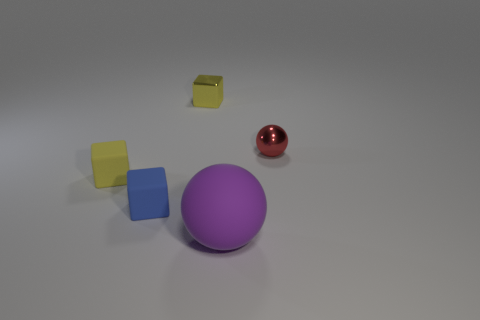There is a thing that is the same material as the red sphere; what is its color?
Provide a succinct answer. Yellow. How many red metal objects are the same size as the blue object?
Give a very brief answer. 1. There is a ball that is behind the purple rubber thing; does it have the same size as the purple object?
Ensure brevity in your answer.  No. The thing that is both in front of the small red sphere and right of the blue matte object has what shape?
Provide a short and direct response. Sphere. There is a yellow matte thing; are there any blue blocks on the left side of it?
Make the answer very short. No. Is there anything else that is the same shape as the tiny blue rubber thing?
Provide a short and direct response. Yes. Does the tiny red object have the same shape as the big rubber object?
Offer a very short reply. Yes. Are there the same number of tiny red objects that are left of the big thing and small red metal things that are to the left of the tiny metallic block?
Offer a terse response. Yes. What number of other things are made of the same material as the purple thing?
Keep it short and to the point. 2. What number of large things are either cylinders or yellow cubes?
Your response must be concise. 0. 